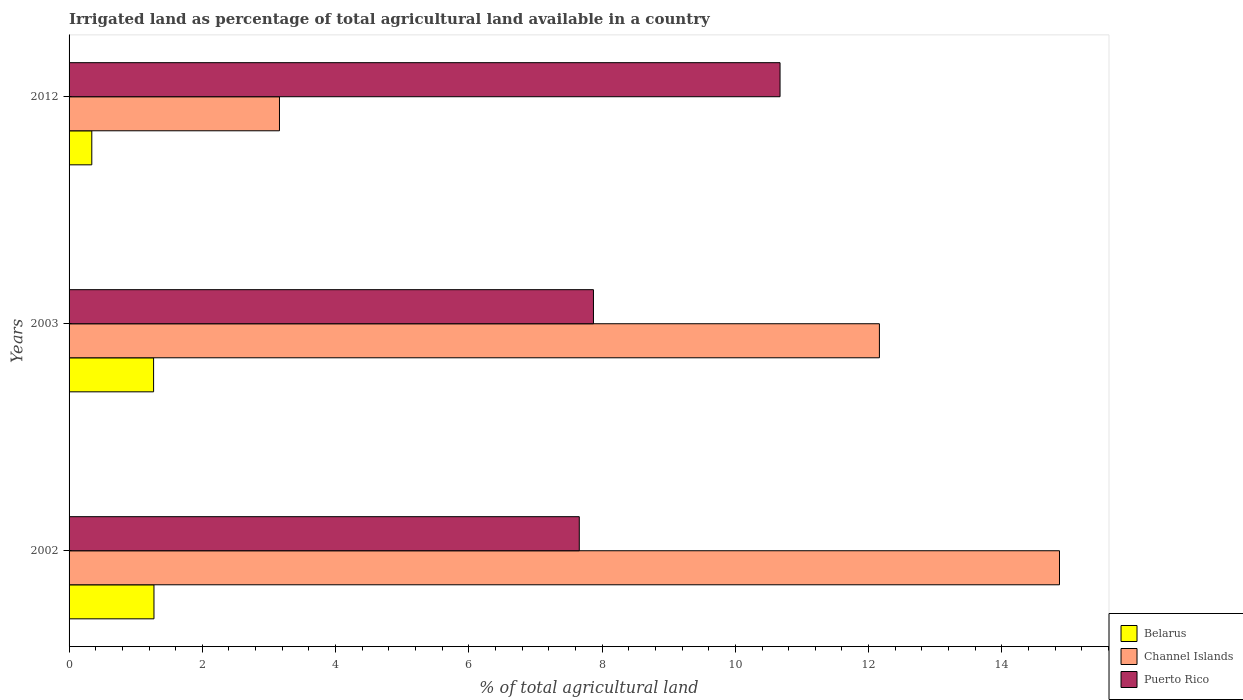Are the number of bars per tick equal to the number of legend labels?
Your answer should be very brief. Yes. How many bars are there on the 2nd tick from the bottom?
Provide a succinct answer. 3. In how many cases, is the number of bars for a given year not equal to the number of legend labels?
Your answer should be very brief. 0. What is the percentage of irrigated land in Puerto Rico in 2002?
Keep it short and to the point. 7.66. Across all years, what is the maximum percentage of irrigated land in Belarus?
Offer a very short reply. 1.27. Across all years, what is the minimum percentage of irrigated land in Channel Islands?
Offer a very short reply. 3.16. In which year was the percentage of irrigated land in Channel Islands maximum?
Give a very brief answer. 2002. What is the total percentage of irrigated land in Belarus in the graph?
Provide a short and direct response. 2.88. What is the difference between the percentage of irrigated land in Channel Islands in 2002 and that in 2003?
Provide a succinct answer. 2.7. What is the difference between the percentage of irrigated land in Puerto Rico in 2012 and the percentage of irrigated land in Belarus in 2002?
Ensure brevity in your answer.  9.4. What is the average percentage of irrigated land in Channel Islands per year?
Provide a succinct answer. 10.06. In the year 2003, what is the difference between the percentage of irrigated land in Puerto Rico and percentage of irrigated land in Belarus?
Make the answer very short. 6.6. What is the ratio of the percentage of irrigated land in Channel Islands in 2003 to that in 2012?
Make the answer very short. 3.85. Is the difference between the percentage of irrigated land in Puerto Rico in 2002 and 2003 greater than the difference between the percentage of irrigated land in Belarus in 2002 and 2003?
Make the answer very short. No. What is the difference between the highest and the second highest percentage of irrigated land in Channel Islands?
Offer a terse response. 2.7. What is the difference between the highest and the lowest percentage of irrigated land in Belarus?
Offer a terse response. 0.93. Is the sum of the percentage of irrigated land in Belarus in 2002 and 2012 greater than the maximum percentage of irrigated land in Channel Islands across all years?
Provide a succinct answer. No. What does the 2nd bar from the top in 2003 represents?
Your response must be concise. Channel Islands. What does the 2nd bar from the bottom in 2012 represents?
Your response must be concise. Channel Islands. Does the graph contain grids?
Ensure brevity in your answer.  No. What is the title of the graph?
Provide a succinct answer. Irrigated land as percentage of total agricultural land available in a country. Does "Slovenia" appear as one of the legend labels in the graph?
Keep it short and to the point. No. What is the label or title of the X-axis?
Provide a succinct answer. % of total agricultural land. What is the label or title of the Y-axis?
Give a very brief answer. Years. What is the % of total agricultural land of Belarus in 2002?
Ensure brevity in your answer.  1.27. What is the % of total agricultural land in Channel Islands in 2002?
Your response must be concise. 14.86. What is the % of total agricultural land in Puerto Rico in 2002?
Ensure brevity in your answer.  7.66. What is the % of total agricultural land in Belarus in 2003?
Give a very brief answer. 1.27. What is the % of total agricultural land in Channel Islands in 2003?
Keep it short and to the point. 12.16. What is the % of total agricultural land of Puerto Rico in 2003?
Provide a short and direct response. 7.87. What is the % of total agricultural land of Belarus in 2012?
Provide a succinct answer. 0.34. What is the % of total agricultural land in Channel Islands in 2012?
Your response must be concise. 3.16. What is the % of total agricultural land in Puerto Rico in 2012?
Your response must be concise. 10.67. Across all years, what is the maximum % of total agricultural land of Belarus?
Your response must be concise. 1.27. Across all years, what is the maximum % of total agricultural land in Channel Islands?
Ensure brevity in your answer.  14.86. Across all years, what is the maximum % of total agricultural land in Puerto Rico?
Ensure brevity in your answer.  10.67. Across all years, what is the minimum % of total agricultural land of Belarus?
Give a very brief answer. 0.34. Across all years, what is the minimum % of total agricultural land of Channel Islands?
Provide a short and direct response. 3.16. Across all years, what is the minimum % of total agricultural land of Puerto Rico?
Keep it short and to the point. 7.66. What is the total % of total agricultural land in Belarus in the graph?
Give a very brief answer. 2.88. What is the total % of total agricultural land of Channel Islands in the graph?
Make the answer very short. 30.18. What is the total % of total agricultural land of Puerto Rico in the graph?
Your answer should be very brief. 26.2. What is the difference between the % of total agricultural land in Belarus in 2002 and that in 2003?
Keep it short and to the point. 0.01. What is the difference between the % of total agricultural land of Channel Islands in 2002 and that in 2003?
Offer a very short reply. 2.7. What is the difference between the % of total agricultural land of Puerto Rico in 2002 and that in 2003?
Your answer should be very brief. -0.21. What is the difference between the % of total agricultural land in Belarus in 2002 and that in 2012?
Offer a very short reply. 0.93. What is the difference between the % of total agricultural land of Channel Islands in 2002 and that in 2012?
Provide a short and direct response. 11.71. What is the difference between the % of total agricultural land in Puerto Rico in 2002 and that in 2012?
Make the answer very short. -3.01. What is the difference between the % of total agricultural land of Belarus in 2003 and that in 2012?
Your answer should be very brief. 0.93. What is the difference between the % of total agricultural land of Channel Islands in 2003 and that in 2012?
Keep it short and to the point. 9. What is the difference between the % of total agricultural land of Puerto Rico in 2003 and that in 2012?
Offer a very short reply. -2.8. What is the difference between the % of total agricultural land of Belarus in 2002 and the % of total agricultural land of Channel Islands in 2003?
Your response must be concise. -10.89. What is the difference between the % of total agricultural land in Belarus in 2002 and the % of total agricultural land in Puerto Rico in 2003?
Your response must be concise. -6.6. What is the difference between the % of total agricultural land in Channel Islands in 2002 and the % of total agricultural land in Puerto Rico in 2003?
Offer a terse response. 6.99. What is the difference between the % of total agricultural land in Belarus in 2002 and the % of total agricultural land in Channel Islands in 2012?
Your response must be concise. -1.88. What is the difference between the % of total agricultural land of Belarus in 2002 and the % of total agricultural land of Puerto Rico in 2012?
Make the answer very short. -9.4. What is the difference between the % of total agricultural land of Channel Islands in 2002 and the % of total agricultural land of Puerto Rico in 2012?
Give a very brief answer. 4.19. What is the difference between the % of total agricultural land in Belarus in 2003 and the % of total agricultural land in Channel Islands in 2012?
Give a very brief answer. -1.89. What is the difference between the % of total agricultural land of Belarus in 2003 and the % of total agricultural land of Puerto Rico in 2012?
Ensure brevity in your answer.  -9.4. What is the difference between the % of total agricultural land of Channel Islands in 2003 and the % of total agricultural land of Puerto Rico in 2012?
Offer a very short reply. 1.49. What is the average % of total agricultural land of Belarus per year?
Your answer should be compact. 0.96. What is the average % of total agricultural land of Channel Islands per year?
Offer a very short reply. 10.06. What is the average % of total agricultural land of Puerto Rico per year?
Make the answer very short. 8.73. In the year 2002, what is the difference between the % of total agricultural land of Belarus and % of total agricultural land of Channel Islands?
Your answer should be very brief. -13.59. In the year 2002, what is the difference between the % of total agricultural land in Belarus and % of total agricultural land in Puerto Rico?
Your answer should be very brief. -6.38. In the year 2002, what is the difference between the % of total agricultural land of Channel Islands and % of total agricultural land of Puerto Rico?
Your response must be concise. 7.21. In the year 2003, what is the difference between the % of total agricultural land of Belarus and % of total agricultural land of Channel Islands?
Give a very brief answer. -10.89. In the year 2003, what is the difference between the % of total agricultural land in Belarus and % of total agricultural land in Puerto Rico?
Make the answer very short. -6.6. In the year 2003, what is the difference between the % of total agricultural land of Channel Islands and % of total agricultural land of Puerto Rico?
Provide a short and direct response. 4.29. In the year 2012, what is the difference between the % of total agricultural land of Belarus and % of total agricultural land of Channel Islands?
Keep it short and to the point. -2.82. In the year 2012, what is the difference between the % of total agricultural land of Belarus and % of total agricultural land of Puerto Rico?
Your answer should be compact. -10.33. In the year 2012, what is the difference between the % of total agricultural land of Channel Islands and % of total agricultural land of Puerto Rico?
Your response must be concise. -7.51. What is the ratio of the % of total agricultural land in Channel Islands in 2002 to that in 2003?
Offer a very short reply. 1.22. What is the ratio of the % of total agricultural land of Puerto Rico in 2002 to that in 2003?
Offer a very short reply. 0.97. What is the ratio of the % of total agricultural land in Belarus in 2002 to that in 2012?
Keep it short and to the point. 3.74. What is the ratio of the % of total agricultural land of Channel Islands in 2002 to that in 2012?
Make the answer very short. 4.71. What is the ratio of the % of total agricultural land of Puerto Rico in 2002 to that in 2012?
Your response must be concise. 0.72. What is the ratio of the % of total agricultural land in Belarus in 2003 to that in 2012?
Keep it short and to the point. 3.72. What is the ratio of the % of total agricultural land in Channel Islands in 2003 to that in 2012?
Your answer should be compact. 3.85. What is the ratio of the % of total agricultural land of Puerto Rico in 2003 to that in 2012?
Provide a succinct answer. 0.74. What is the difference between the highest and the second highest % of total agricultural land of Belarus?
Give a very brief answer. 0.01. What is the difference between the highest and the second highest % of total agricultural land in Channel Islands?
Make the answer very short. 2.7. What is the difference between the highest and the second highest % of total agricultural land of Puerto Rico?
Your response must be concise. 2.8. What is the difference between the highest and the lowest % of total agricultural land in Belarus?
Offer a terse response. 0.93. What is the difference between the highest and the lowest % of total agricultural land of Channel Islands?
Your answer should be compact. 11.71. What is the difference between the highest and the lowest % of total agricultural land of Puerto Rico?
Provide a succinct answer. 3.01. 